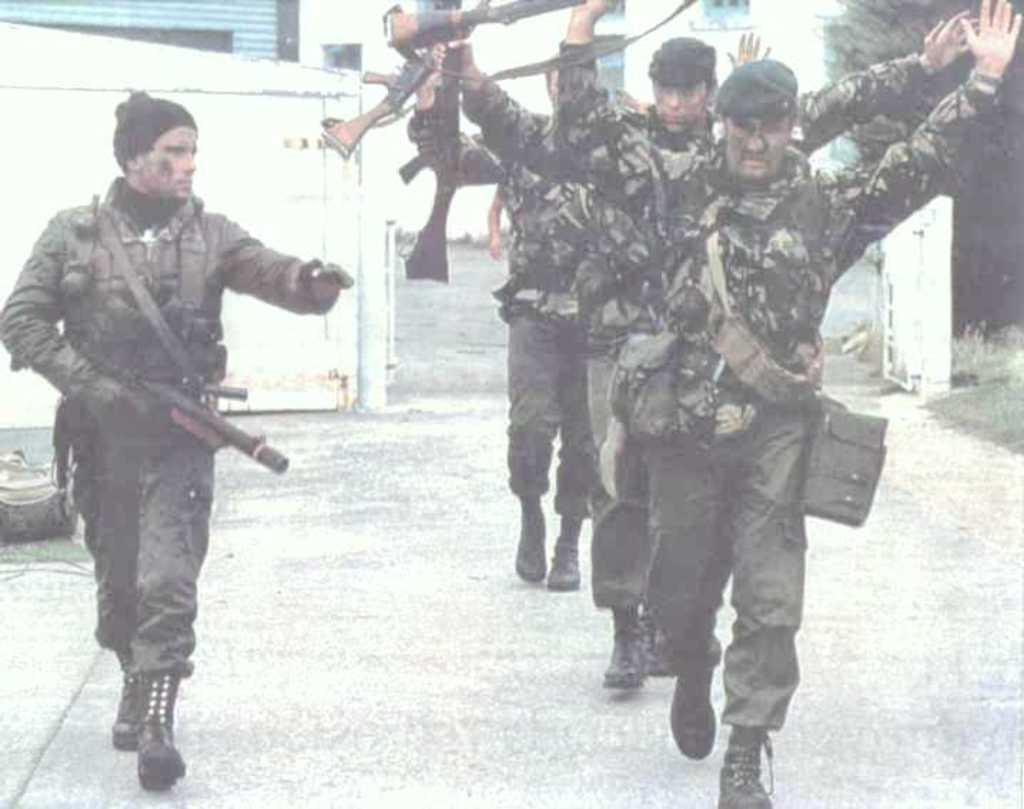How many people are in the image? There are four persons in the image. What are the persons doing in the image? The persons are walking and holding guns. Can you describe any objects or items in the image? There is a bag on the left side of the image and a tree on the right side of the image. What can be seen in the background of the image? There is a building in the background of the image. What type of plant is making the persons in the image cough? There is no plant present in the image, nor is there any indication that the persons are coughing. 